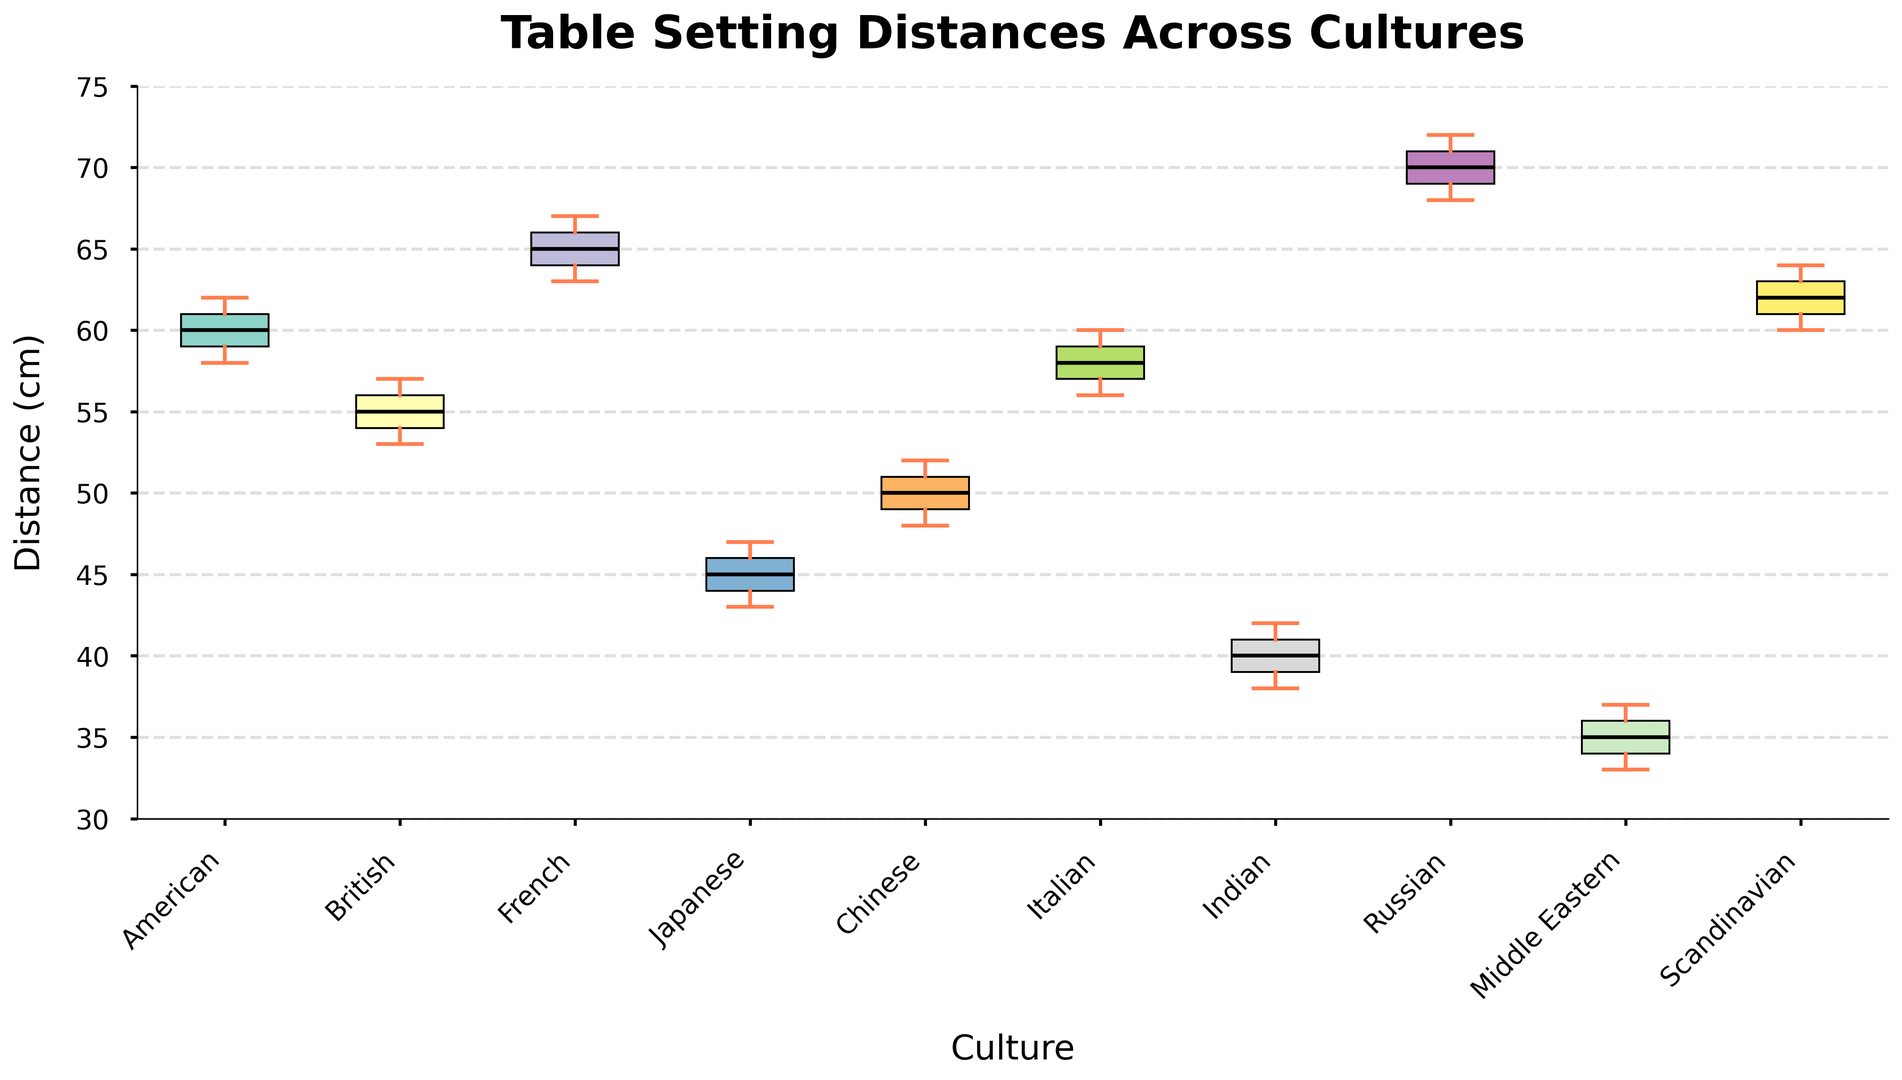What's the median table setting distance for American culture? To find the median, sort the distances for American culture: [58, 59, 60, 61, 62]. The median is the middle value.
Answer: 60 cm Which culture has the smallest median table setting distance? Observe the central line (median) within each box plot. The Middle Eastern culture's box plot has the lowest median line.
Answer: Middle Eastern Compare the interquartile range (IQR) of British and French cultures. Which is larger? The IQR is the length of the box. Visually compare the length of the boxes for British and French cultures. The French culture's box is slightly larger.
Answer: French Which culture has the widest range of table setting distances? The range is the distance between the smallest and largest values (whiskers). Look for the box plot with the longest distance between whiskers. The Russian culture has the widest range.
Answer: Russian Are there any cultures with overlapping Interquartile Ranges (IQRs)? If yes, which ones? Look for boxes that overlap on the y-axis. Cultures with overlapping IQRs include American and Italian, British and Italian.
Answer: American and Italian, British and Italian What is the difference between the median table setting distances of Japanese and Russian cultures? Find the median for both cultures (Japanese: 45 cm, Russian: 70 cm) and subtract the smaller median from the larger one. 70 - 45 = 25 cm.
Answer: 25 cm Which culture's table setting distances exhibit the least variability? Variability can be inferred from the length of the whiskers and the size of the box. The Middle Eastern culture has the shortest whiskers and box, indicating the least variability.
Answer: Middle Eastern How does the median distance for Chinese culture compare with that of Scandinavian culture? Compare the heights of the median lines in the box plots for Chinese (50 cm) and Scandinavian (62 cm) cultures. The median for Scandinavian is higher.
Answer: Scandinavian is higher Is the table setting distance for Indian culture ever higher than the median distance for American culture? The highest distance within the Indian culture is 42 cm, while the median for American culture is 60 cm. 42 < 60, so it is never higher.
Answer: No 